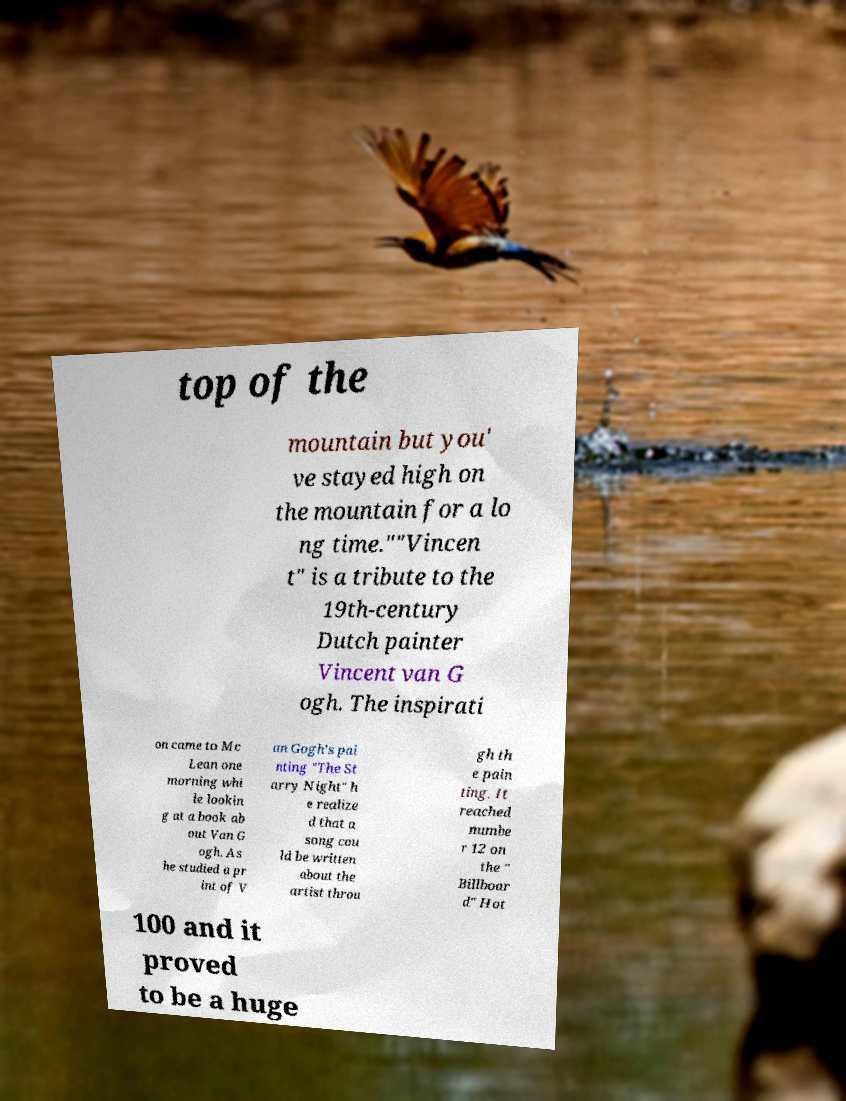Please read and relay the text visible in this image. What does it say? top of the mountain but you' ve stayed high on the mountain for a lo ng time.""Vincen t" is a tribute to the 19th-century Dutch painter Vincent van G ogh. The inspirati on came to Mc Lean one morning whi le lookin g at a book ab out Van G ogh. As he studied a pr int of V an Gogh's pai nting "The St arry Night" h e realize d that a song cou ld be written about the artist throu gh th e pain ting. It reached numbe r 12 on the " Billboar d" Hot 100 and it proved to be a huge 